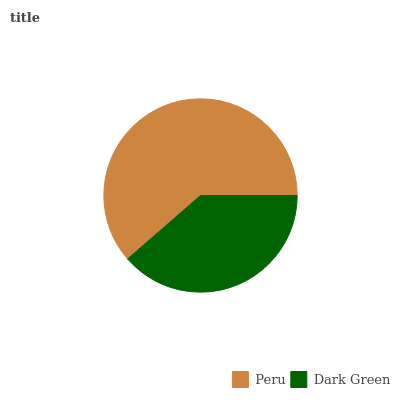Is Dark Green the minimum?
Answer yes or no. Yes. Is Peru the maximum?
Answer yes or no. Yes. Is Dark Green the maximum?
Answer yes or no. No. Is Peru greater than Dark Green?
Answer yes or no. Yes. Is Dark Green less than Peru?
Answer yes or no. Yes. Is Dark Green greater than Peru?
Answer yes or no. No. Is Peru less than Dark Green?
Answer yes or no. No. Is Peru the high median?
Answer yes or no. Yes. Is Dark Green the low median?
Answer yes or no. Yes. Is Dark Green the high median?
Answer yes or no. No. Is Peru the low median?
Answer yes or no. No. 